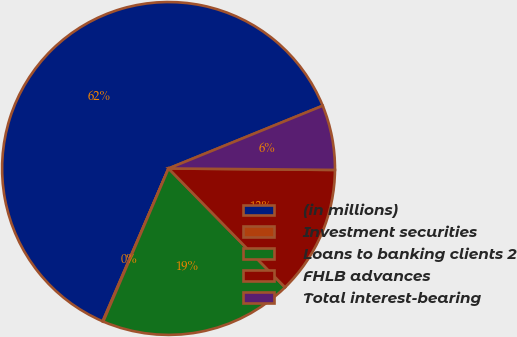<chart> <loc_0><loc_0><loc_500><loc_500><pie_chart><fcel>(in millions)<fcel>Investment securities<fcel>Loans to banking clients 2<fcel>FHLB advances<fcel>Total interest-bearing<nl><fcel>62.36%<fcel>0.06%<fcel>18.75%<fcel>12.52%<fcel>6.29%<nl></chart> 